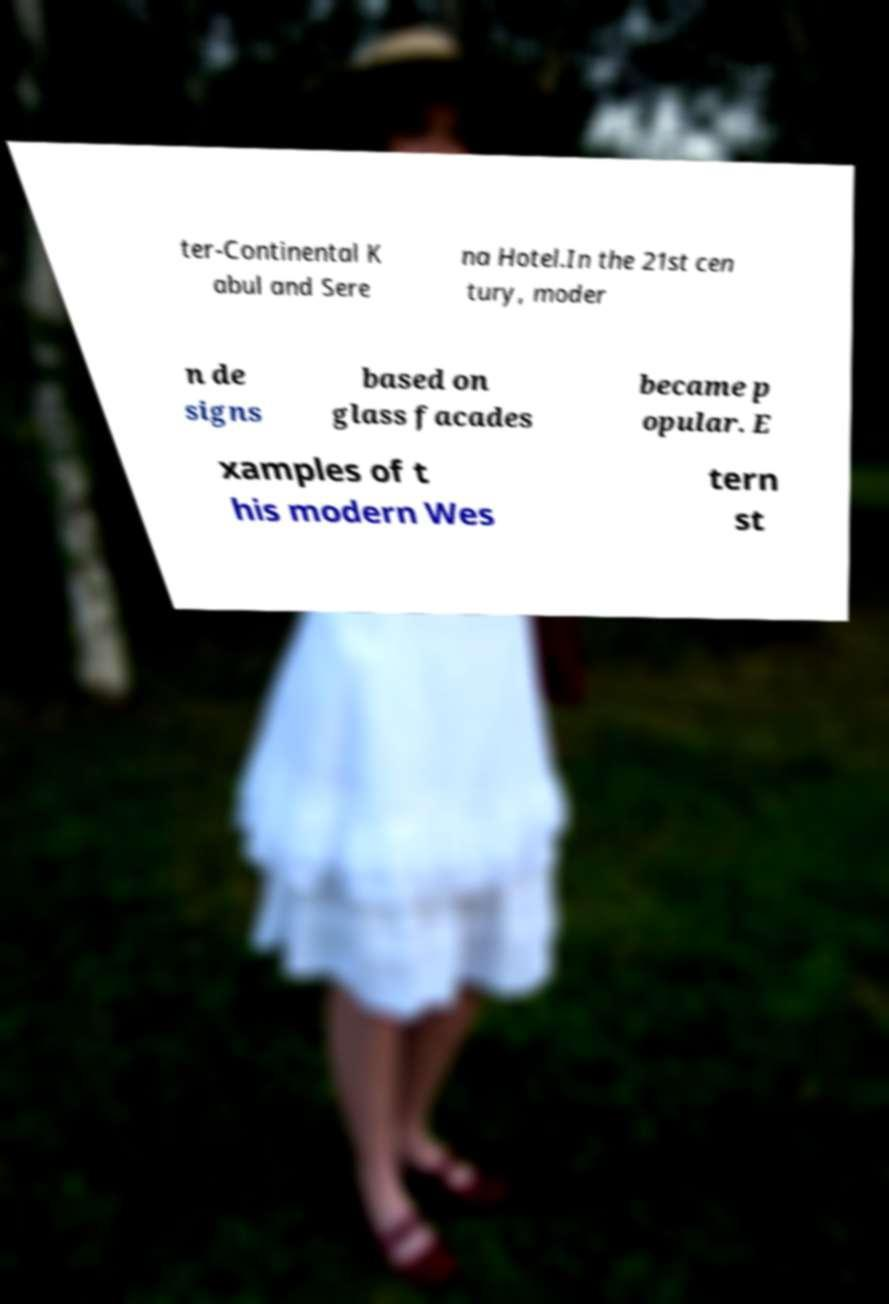There's text embedded in this image that I need extracted. Can you transcribe it verbatim? ter-Continental K abul and Sere na Hotel.In the 21st cen tury, moder n de signs based on glass facades became p opular. E xamples of t his modern Wes tern st 